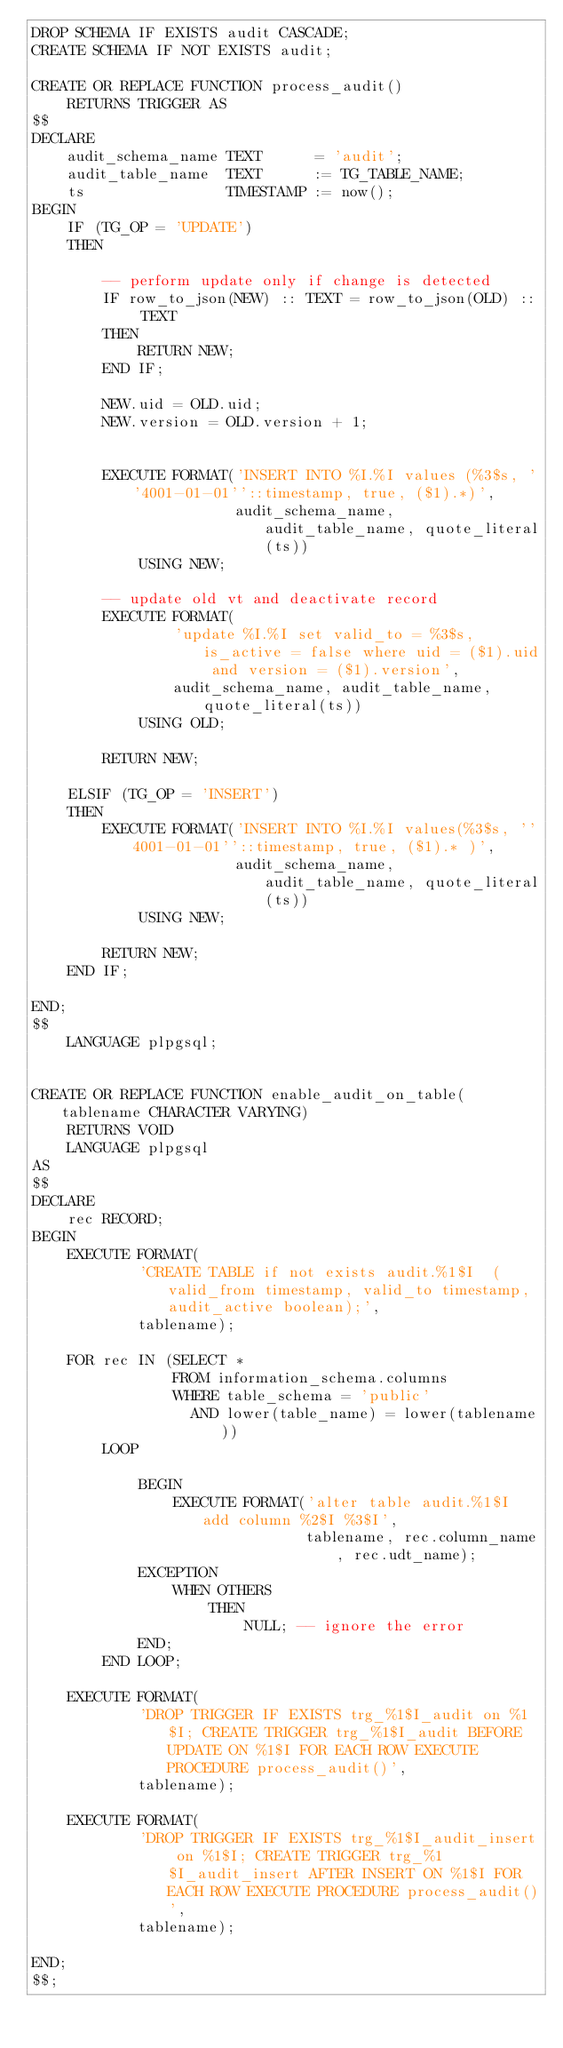Convert code to text. <code><loc_0><loc_0><loc_500><loc_500><_SQL_>DROP SCHEMA IF EXISTS audit CASCADE;
CREATE SCHEMA IF NOT EXISTS audit;

CREATE OR REPLACE FUNCTION process_audit()
    RETURNS TRIGGER AS
$$
DECLARE
    audit_schema_name TEXT      = 'audit';
    audit_table_name  TEXT      := TG_TABLE_NAME;
    ts                TIMESTAMP := now();
BEGIN
    IF (TG_OP = 'UPDATE')
    THEN

        -- perform update only if change is detected
        IF row_to_json(NEW) :: TEXT = row_to_json(OLD) :: TEXT
        THEN
            RETURN NEW;
        END IF;

        NEW.uid = OLD.uid;
        NEW.version = OLD.version + 1;


        EXECUTE FORMAT('INSERT INTO %I.%I values (%3$s, ''4001-01-01''::timestamp, true, ($1).*)',
                       audit_schema_name, audit_table_name, quote_literal(ts))
            USING NEW;

        -- update old vt and deactivate record
        EXECUTE FORMAT(
                'update %I.%I set valid_to = %3$s, is_active = false where uid = ($1).uid and version = ($1).version',
                audit_schema_name, audit_table_name, quote_literal(ts))
            USING OLD;

        RETURN NEW;

    ELSIF (TG_OP = 'INSERT')
    THEN
        EXECUTE FORMAT('INSERT INTO %I.%I values(%3$s, ''4001-01-01''::timestamp, true, ($1).* )',
                       audit_schema_name, audit_table_name, quote_literal(ts))
            USING NEW;

        RETURN NEW;
    END IF;

END;
$$
    LANGUAGE plpgsql;


CREATE OR REPLACE FUNCTION enable_audit_on_table(tablename CHARACTER VARYING)
    RETURNS VOID
    LANGUAGE plpgsql
AS
$$
DECLARE
    rec RECORD;
BEGIN
    EXECUTE FORMAT(
            'CREATE TABLE if not exists audit.%1$I  (valid_from timestamp, valid_to timestamp, audit_active boolean);',
            tablename);

    FOR rec IN (SELECT *
                FROM information_schema.columns
                WHERE table_schema = 'public'
                  AND lower(table_name) = lower(tablename))
        LOOP

            BEGIN
                EXECUTE FORMAT('alter table audit.%1$I add column %2$I %3$I',
                               tablename, rec.column_name, rec.udt_name);
            EXCEPTION
                WHEN OTHERS
                    THEN
                        NULL; -- ignore the error
            END;
        END LOOP;

    EXECUTE FORMAT(
            'DROP TRIGGER IF EXISTS trg_%1$I_audit on %1$I; CREATE TRIGGER trg_%1$I_audit BEFORE UPDATE ON %1$I FOR EACH ROW EXECUTE PROCEDURE process_audit()',
            tablename);

    EXECUTE FORMAT(
            'DROP TRIGGER IF EXISTS trg_%1$I_audit_insert on %1$I; CREATE TRIGGER trg_%1$I_audit_insert AFTER INSERT ON %1$I FOR EACH ROW EXECUTE PROCEDURE process_audit()',
            tablename);

END;
$$;
</code> 